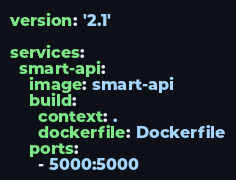<code> <loc_0><loc_0><loc_500><loc_500><_YAML_>version: '2.1'

services:
  smart-api:
    image: smart-api
    build:
      context: .
      dockerfile: Dockerfile
    ports:
      - 5000:5000
</code> 